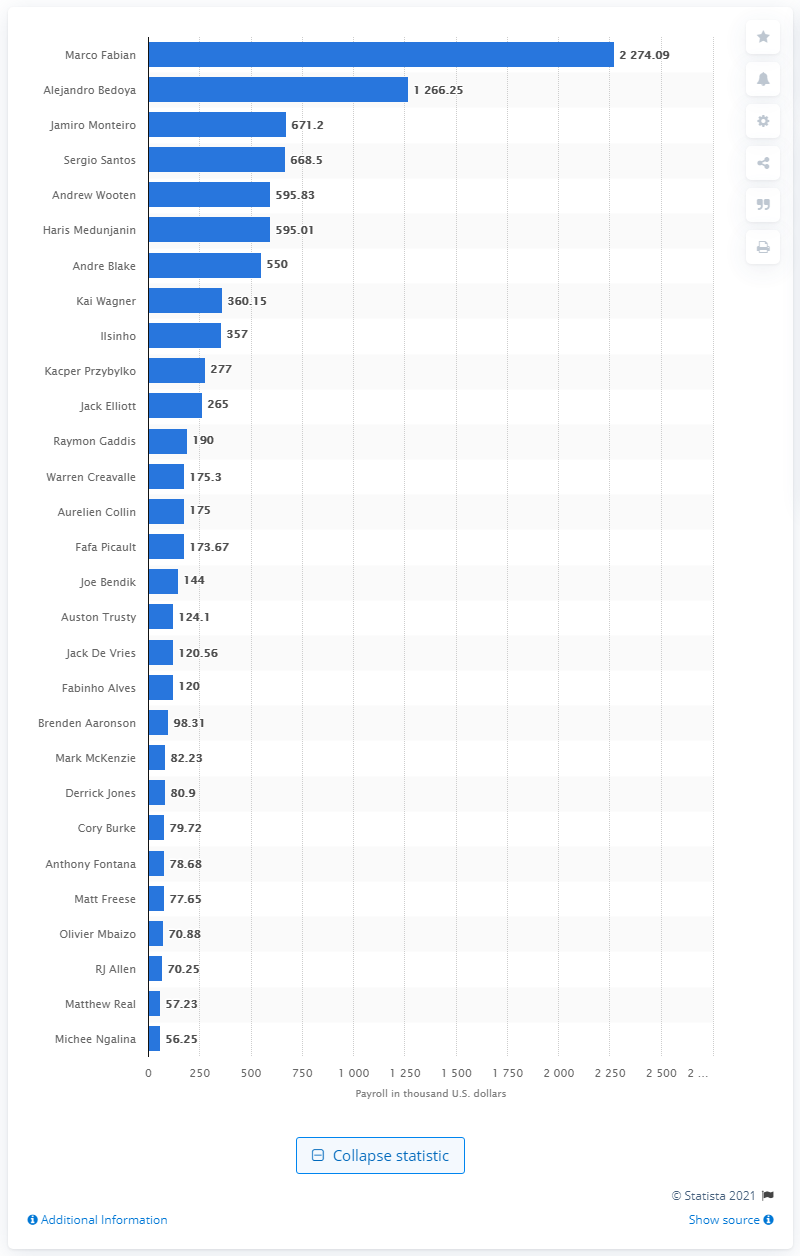Highlight a few significant elements in this photo. The person who received a salary of 2.27 million dollars is Marco Fabian. 